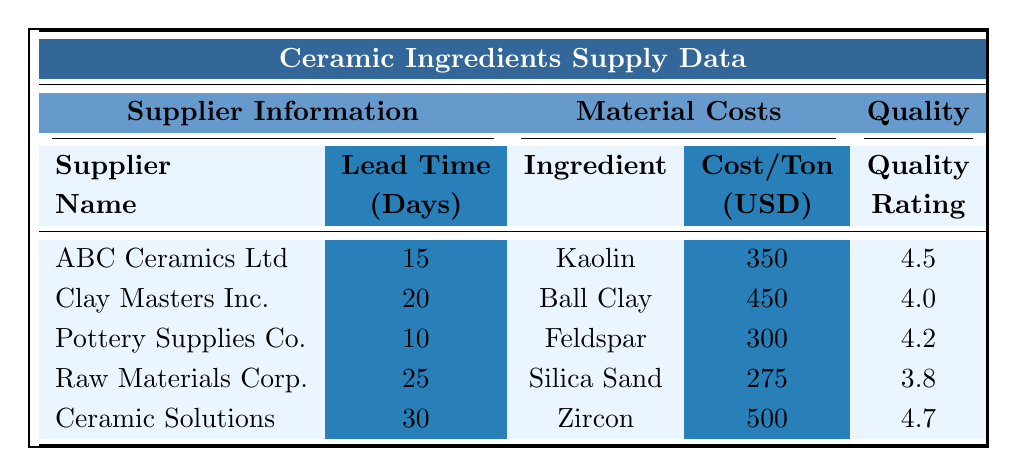What is the lead time for Pottery Supplies Co.? According to the table, the lead time specific to Pottery Supplies Co. is listed as 10 days.
Answer: 10 days What is the unit cost per ton for Feldspar? The table indicates that the unit cost per ton for Feldspar is listed as 300 USD.
Answer: 300 USD Which supplier has the highest shipping cost? Looking at the table, Ceramic Solutions has the highest shipping cost of 250 USD.
Answer: 250 USD Is the quality rating for Raw Materials Corp. higher than 4.0? The quality rating for Raw Materials Corp. is 3.8, which is less than 4.0. Thus, the statement is false.
Answer: No What is the average unit cost per ton for the ceramic ingredients listed? The unit costs are 350, 450, 300, 275, and 500 USD. Summing these gives 1875 USD. There are 5 ingredients, so the average is 1875 / 5 = 375.
Answer: 375 USD Which ingredient has the lowest unit cost per ton? From the listed unit costs (350, 450, 300, 275, 500), Silica Sand at 275 USD has the lowest value.
Answer: Silica Sand Which suppliers have a quality rating of 4.5 or higher? Referring to the table, the suppliers that have a quality rating of 4.5 or higher are ABC Ceramics Ltd (4.5) and Ceramic Solutions (4.7).
Answer: ABC Ceramics Ltd and Ceramic Solutions What is the total shipping cost for all suppliers combined? The shipping costs are 120, 150, 100, 200, and 250 USD. Adding these results in 820 USD, which is the total shipping cost for all suppliers.
Answer: 820 USD How many tons of Ball Clay are available? The table states that the quantity available for Ball Clay is 800 tons.
Answer: 800 tons If we consider only suppliers with a lead time of 20 days or less, which supplier provides Kaolin? From the table, the suppliers with a lead time of 20 days or less are ABC Ceramics Ltd (15 days) and Pottery Supplies Co. (10 days). However, Pottery Supplies Co. supplies Feldspar, not Kaolin. Therefore, none supply Kaolin under 20 days lead time.
Answer: None What is the difference in lead time between the fastest and slowest suppliers? The fastest lead time is 10 days from Pottery Supplies Co., and the slowest is 30 days from Ceramic Solutions. Therefore, the difference is 30 - 10 = 20 days.
Answer: 20 days 